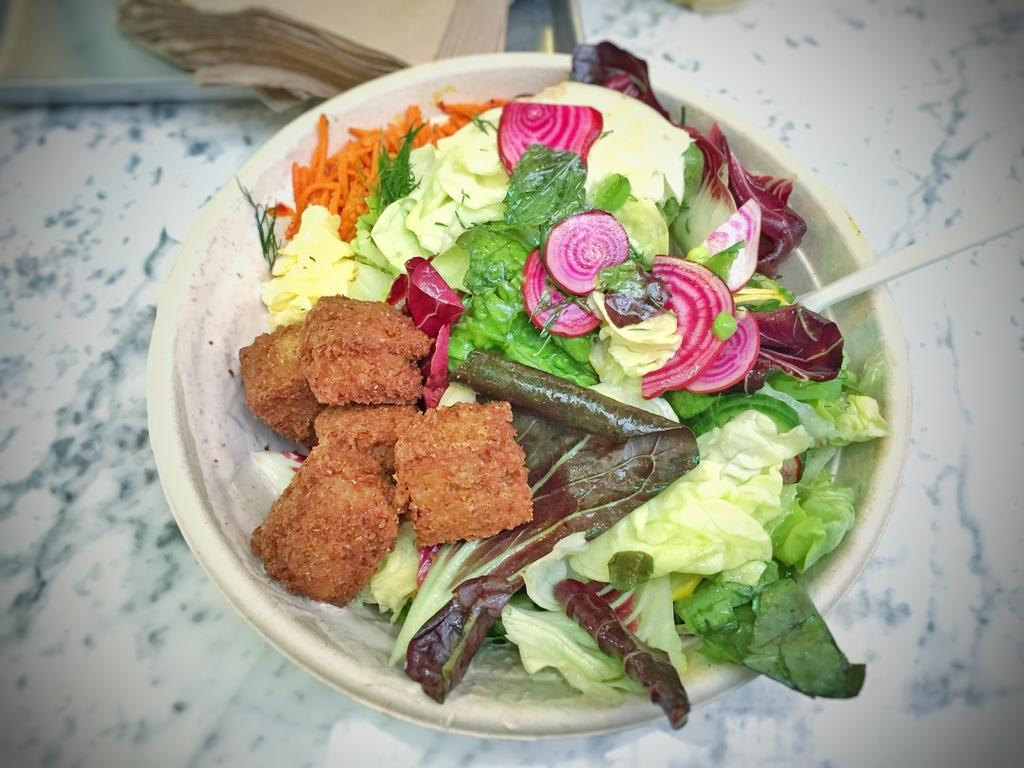What is in the bowl that is visible in the image? The bowl contains green leaves, onion pieces, beetroot pieces, and carrot. What type of vegetables can be found in the bowl? The bowl contains onion pieces, beetroot pieces, and carrot. What color are the green leaves in the bowl? The color of the green leaves in the bowl cannot be determined from the image. What is visible in the background of the image? There are papers in the background of the image. What type of birth can be seen in the image? There is no birth present in the image; it features a bowl with various vegetables. What is the angle of the slope in the image? There is no slope present in the image; it features a bowl with various vegetables and papers in the background. 